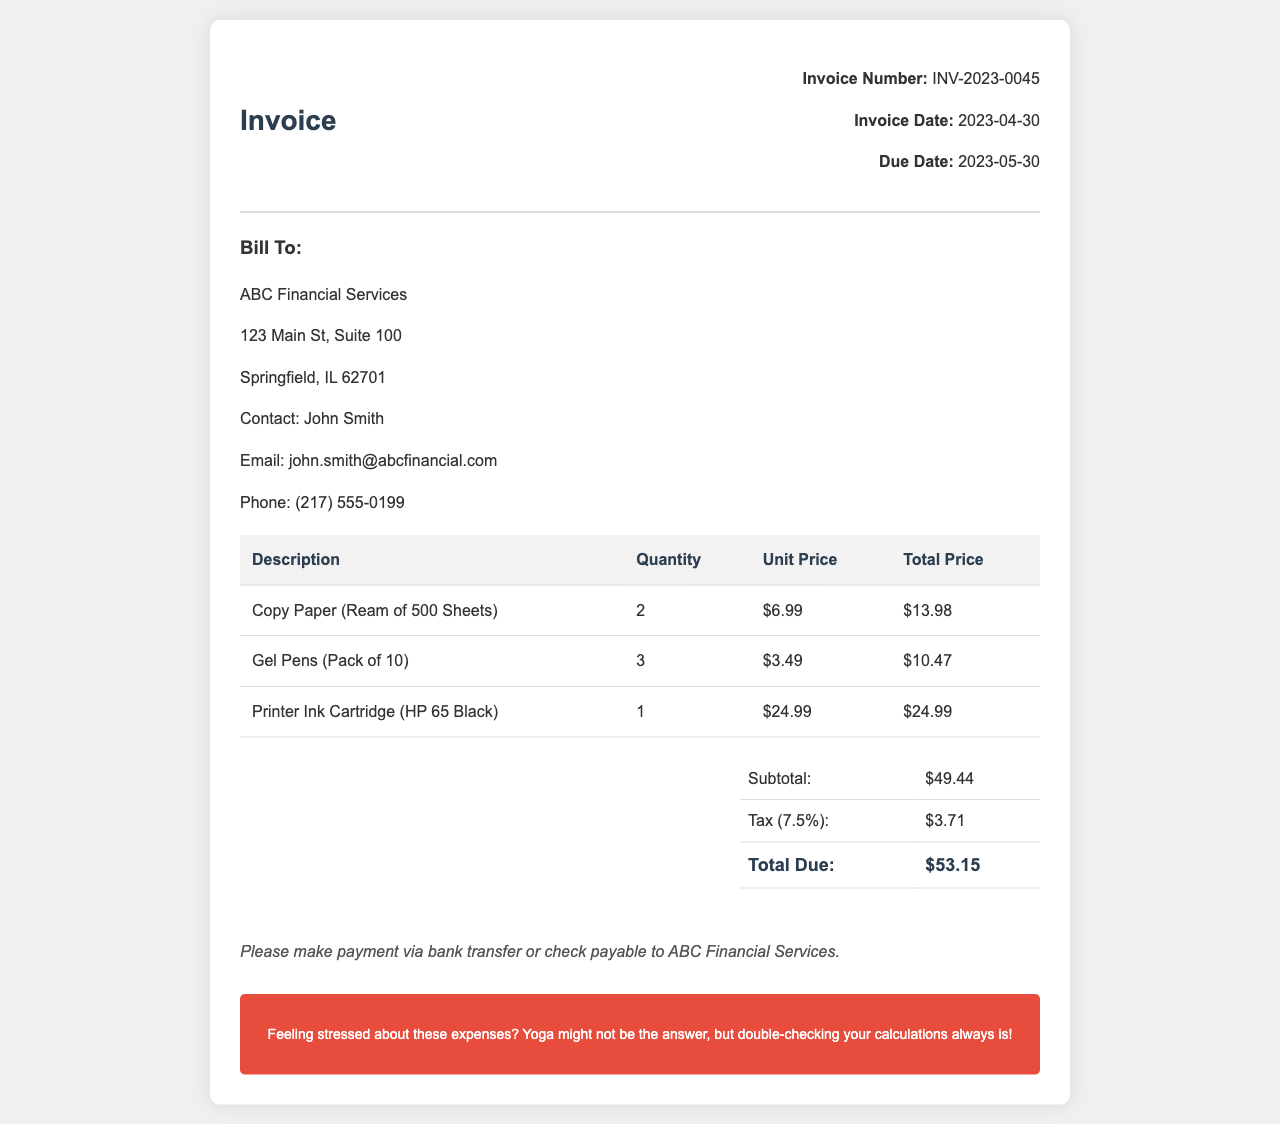What is the invoice number? The invoice number is listed in the document for identification, which is INV-2023-0045.
Answer: INV-2023-0045 What is the total due amount? The document states the total amount that needs to be paid is the sum of the subtotal and tax, which is $53.15.
Answer: $53.15 How much was paid for printer ink? The total price for the printer ink cartridge is provided in the document, which is $24.99.
Answer: $24.99 What is the quantity of gel pens purchased? The document includes the number of gel pen packs purchased, which is 3.
Answer: 3 What is the tax percentage applied? The tax amount is shown as 7.5% in the invoice, indicating the percentage applied to the subtotal.
Answer: 7.5% What is the subtotal amount before tax? The subtotal is calculated before tax is added, which is $49.44 as shown in the invoice.
Answer: $49.44 Who is the contact person for the billing? The document lists the contact person for the billing, which is John Smith.
Answer: John Smith What payment methods are suggested? The document provides instructions on how to make payments, which mentions bank transfer or check.
Answer: Bank transfer or check 